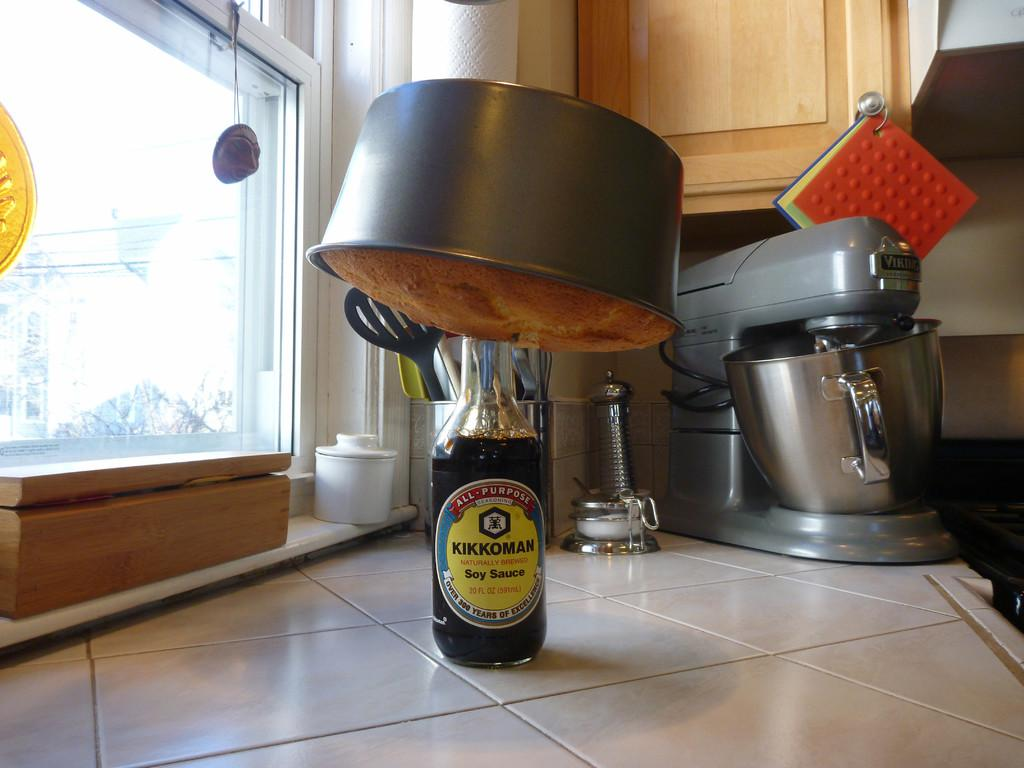<image>
Create a compact narrative representing the image presented. a bottle with a yellow sticker that says Soy Sauce 